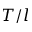Convert formula to latex. <formula><loc_0><loc_0><loc_500><loc_500>T / l</formula> 